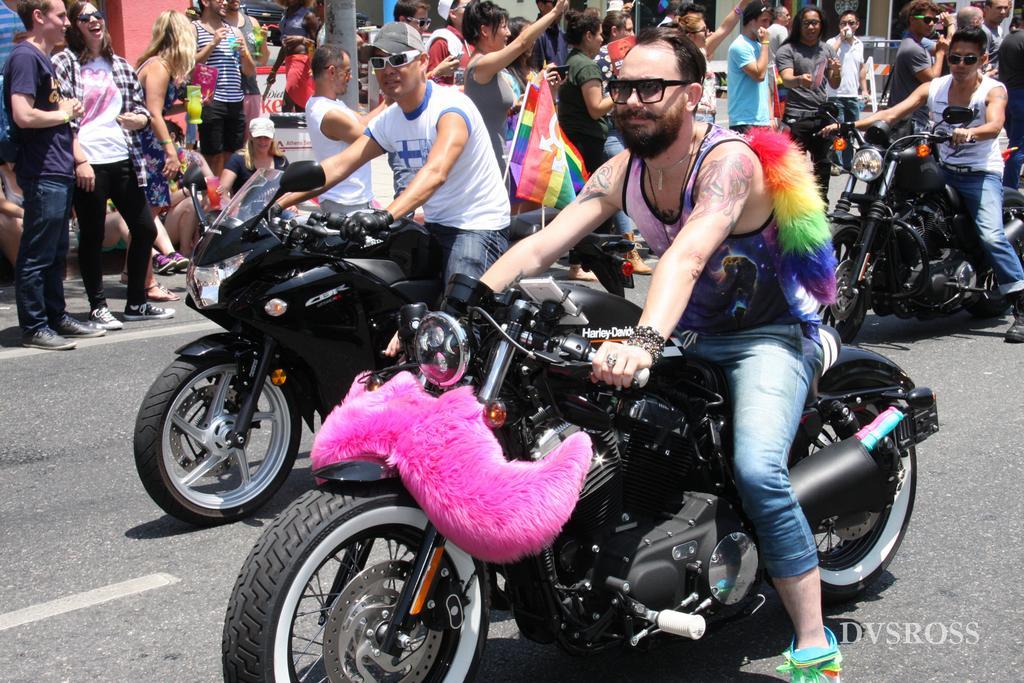Could you give a brief overview of what you see in this image? Here, we see three people riding on riding bike on road. The one with white t-shirt and black jeans is wearing spectacles. We can see many people behind them who are encouraging them. Here, the girl with white t-shirt wearing goggles is laughing. The one with a flag holding in her hands is encouraging them. 